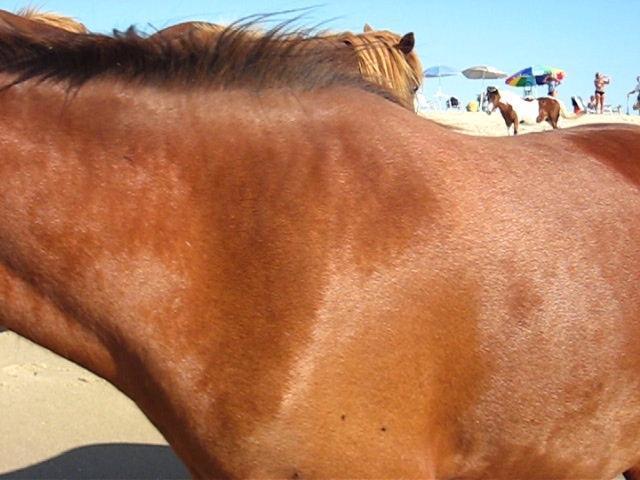How many umbrella's are visible?
Give a very brief answer. 3. How many animals in the picture?
Give a very brief answer. 2. How many horses are in the photo?
Give a very brief answer. 2. 